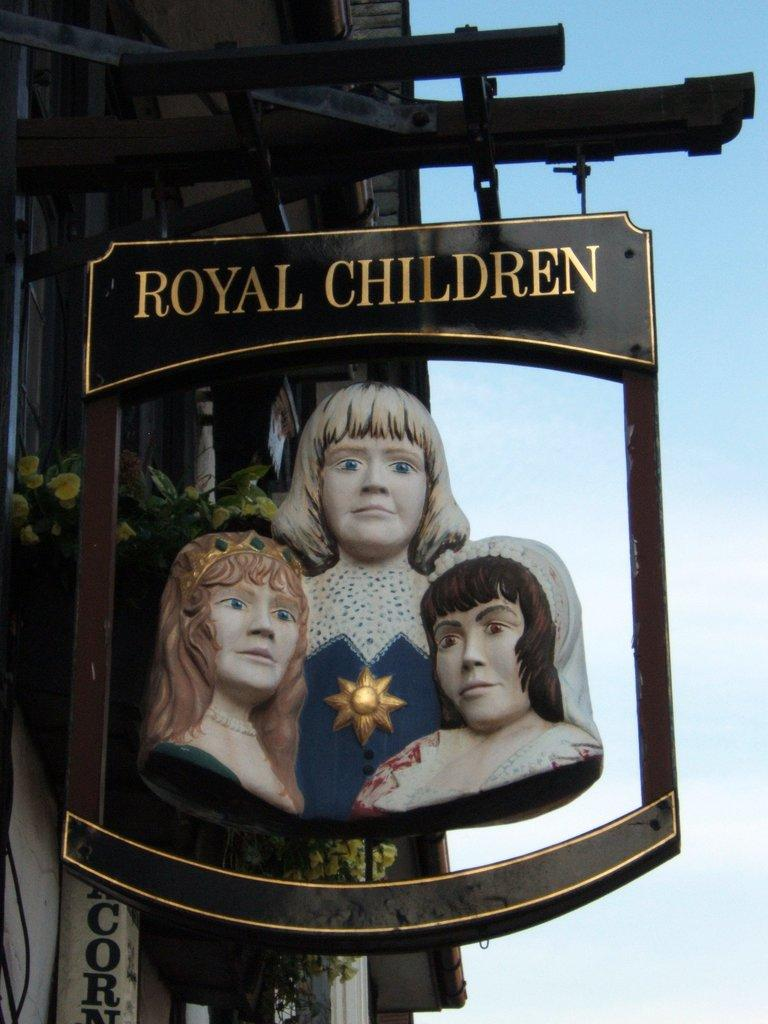What type of structure is present in the image? There is a house in the image. What type of plants can be seen in the image? There are flowers in the image. the image. Can you describe an object with writing in the image? Yes, there is an object with writing on it in the image. What type of artwork is present in the image? There is a sculpture of a woman in the image. What can be seen in the background of the image? The sky is visible in the background of the image. How many gloves can be seen in the image? There are no gloves present in the image. Are there any bears visible in the image? No, there are no bears present in the image. 